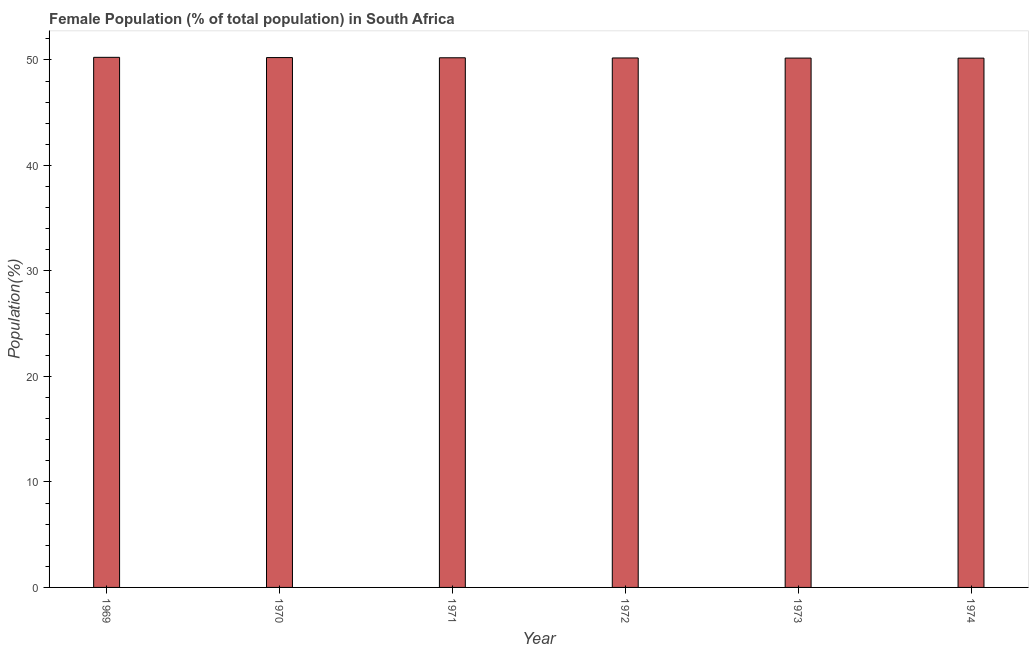Does the graph contain any zero values?
Provide a short and direct response. No. Does the graph contain grids?
Offer a terse response. No. What is the title of the graph?
Give a very brief answer. Female Population (% of total population) in South Africa. What is the label or title of the X-axis?
Offer a terse response. Year. What is the label or title of the Y-axis?
Ensure brevity in your answer.  Population(%). What is the female population in 1970?
Your answer should be very brief. 50.23. Across all years, what is the maximum female population?
Your response must be concise. 50.25. Across all years, what is the minimum female population?
Give a very brief answer. 50.17. In which year was the female population maximum?
Provide a succinct answer. 1969. In which year was the female population minimum?
Your answer should be compact. 1974. What is the sum of the female population?
Offer a terse response. 301.22. What is the difference between the female population in 1971 and 1972?
Your response must be concise. 0.02. What is the average female population per year?
Give a very brief answer. 50.2. What is the median female population?
Ensure brevity in your answer.  50.2. In how many years, is the female population greater than 20 %?
Your answer should be very brief. 6. What is the ratio of the female population in 1971 to that in 1974?
Provide a succinct answer. 1. Is the female population in 1970 less than that in 1974?
Give a very brief answer. No. Is the difference between the female population in 1972 and 1973 greater than the difference between any two years?
Provide a succinct answer. No. What is the difference between the highest and the second highest female population?
Keep it short and to the point. 0.02. What is the difference between the highest and the lowest female population?
Give a very brief answer. 0.08. In how many years, is the female population greater than the average female population taken over all years?
Make the answer very short. 3. What is the Population(%) of 1969?
Offer a terse response. 50.25. What is the Population(%) of 1970?
Your answer should be compact. 50.23. What is the Population(%) in 1971?
Provide a short and direct response. 50.21. What is the Population(%) of 1972?
Provide a short and direct response. 50.19. What is the Population(%) of 1973?
Provide a short and direct response. 50.18. What is the Population(%) of 1974?
Offer a terse response. 50.17. What is the difference between the Population(%) in 1969 and 1970?
Ensure brevity in your answer.  0.02. What is the difference between the Population(%) in 1969 and 1971?
Provide a short and direct response. 0.04. What is the difference between the Population(%) in 1969 and 1972?
Your answer should be compact. 0.06. What is the difference between the Population(%) in 1969 and 1973?
Your answer should be compact. 0.07. What is the difference between the Population(%) in 1969 and 1974?
Your response must be concise. 0.08. What is the difference between the Population(%) in 1970 and 1971?
Your answer should be compact. 0.02. What is the difference between the Population(%) in 1970 and 1972?
Ensure brevity in your answer.  0.04. What is the difference between the Population(%) in 1970 and 1973?
Give a very brief answer. 0.05. What is the difference between the Population(%) in 1970 and 1974?
Your answer should be very brief. 0.05. What is the difference between the Population(%) in 1971 and 1972?
Keep it short and to the point. 0.02. What is the difference between the Population(%) in 1971 and 1973?
Provide a short and direct response. 0.03. What is the difference between the Population(%) in 1971 and 1974?
Provide a succinct answer. 0.03. What is the difference between the Population(%) in 1972 and 1973?
Your answer should be very brief. 0.01. What is the difference between the Population(%) in 1972 and 1974?
Your response must be concise. 0.02. What is the difference between the Population(%) in 1973 and 1974?
Your answer should be compact. 0.01. What is the ratio of the Population(%) in 1969 to that in 1974?
Your answer should be very brief. 1. What is the ratio of the Population(%) in 1970 to that in 1972?
Give a very brief answer. 1. What is the ratio of the Population(%) in 1970 to that in 1973?
Keep it short and to the point. 1. 